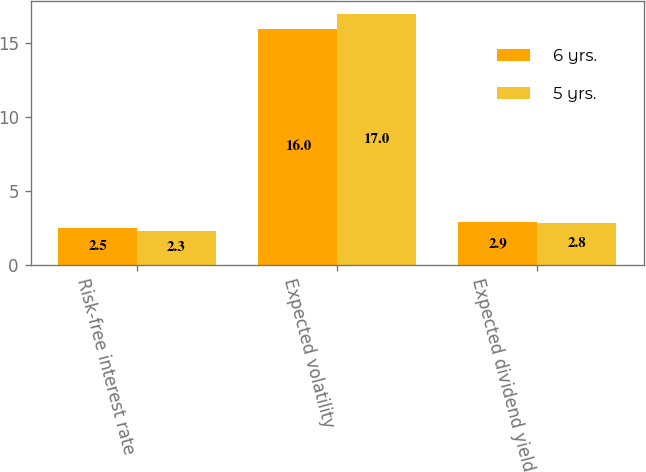<chart> <loc_0><loc_0><loc_500><loc_500><stacked_bar_chart><ecel><fcel>Risk-free interest rate<fcel>Expected volatility<fcel>Expected dividend yield<nl><fcel>6 yrs.<fcel>2.5<fcel>16<fcel>2.9<nl><fcel>5 yrs.<fcel>2.3<fcel>17<fcel>2.8<nl></chart> 